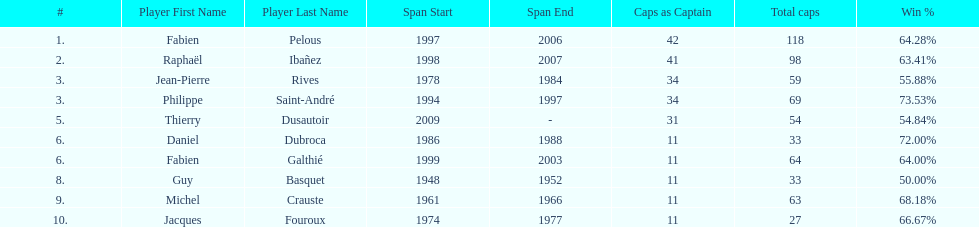Which captain served the least amount of time? Daniel Dubroca. 